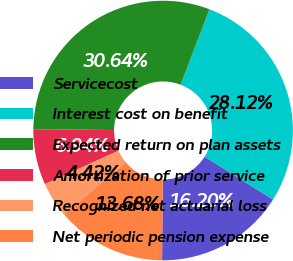Convert chart to OTSL. <chart><loc_0><loc_0><loc_500><loc_500><pie_chart><fcel>Servicecost<fcel>Interest cost on benefit<fcel>Expected return on plan assets<fcel>Amortization of prior service<fcel>Recognized net actuarial loss<fcel>Net periodic pension expense<nl><fcel>16.2%<fcel>28.12%<fcel>30.64%<fcel>6.94%<fcel>4.42%<fcel>13.68%<nl></chart> 